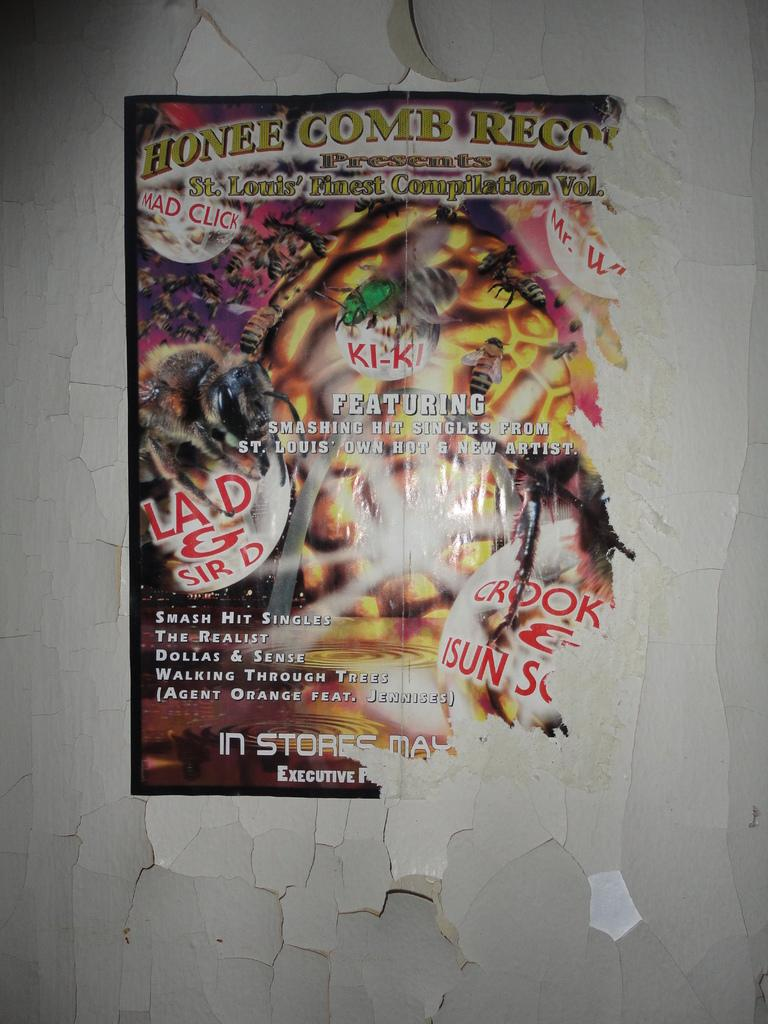<image>
Present a compact description of the photo's key features. Honee Comb Records released a compilation of music from St. Louis. 